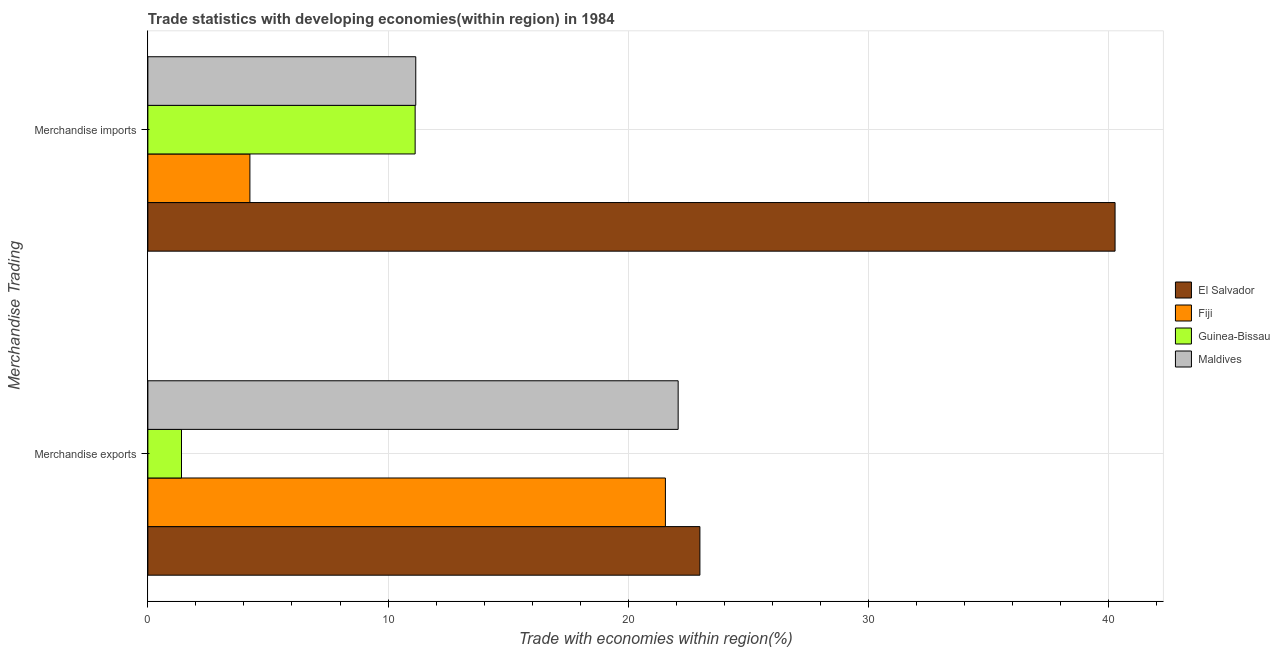What is the label of the 2nd group of bars from the top?
Keep it short and to the point. Merchandise exports. What is the merchandise imports in Fiji?
Make the answer very short. 4.25. Across all countries, what is the maximum merchandise exports?
Your answer should be compact. 22.98. Across all countries, what is the minimum merchandise imports?
Keep it short and to the point. 4.25. In which country was the merchandise imports maximum?
Give a very brief answer. El Salvador. In which country was the merchandise imports minimum?
Your answer should be very brief. Fiji. What is the total merchandise exports in the graph?
Your response must be concise. 68.01. What is the difference between the merchandise exports in Guinea-Bissau and that in Fiji?
Offer a very short reply. -20.15. What is the difference between the merchandise exports in Fiji and the merchandise imports in Guinea-Bissau?
Make the answer very short. 10.42. What is the average merchandise imports per country?
Provide a short and direct response. 16.7. What is the difference between the merchandise exports and merchandise imports in El Salvador?
Your answer should be very brief. -17.28. In how many countries, is the merchandise exports greater than 12 %?
Your response must be concise. 3. What is the ratio of the merchandise exports in El Salvador to that in Fiji?
Your answer should be compact. 1.07. Is the merchandise imports in Maldives less than that in Guinea-Bissau?
Give a very brief answer. No. What does the 1st bar from the top in Merchandise exports represents?
Offer a terse response. Maldives. What does the 3rd bar from the bottom in Merchandise imports represents?
Your answer should be compact. Guinea-Bissau. How many bars are there?
Give a very brief answer. 8. Are all the bars in the graph horizontal?
Offer a very short reply. Yes. How many countries are there in the graph?
Provide a short and direct response. 4. Are the values on the major ticks of X-axis written in scientific E-notation?
Keep it short and to the point. No. Does the graph contain any zero values?
Make the answer very short. No. Does the graph contain grids?
Your answer should be very brief. Yes. Where does the legend appear in the graph?
Provide a succinct answer. Center right. How many legend labels are there?
Make the answer very short. 4. How are the legend labels stacked?
Provide a succinct answer. Vertical. What is the title of the graph?
Provide a short and direct response. Trade statistics with developing economies(within region) in 1984. What is the label or title of the X-axis?
Provide a short and direct response. Trade with economies within region(%). What is the label or title of the Y-axis?
Your answer should be very brief. Merchandise Trading. What is the Trade with economies within region(%) in El Salvador in Merchandise exports?
Make the answer very short. 22.98. What is the Trade with economies within region(%) in Fiji in Merchandise exports?
Offer a terse response. 21.55. What is the Trade with economies within region(%) in Guinea-Bissau in Merchandise exports?
Provide a succinct answer. 1.4. What is the Trade with economies within region(%) in Maldives in Merchandise exports?
Provide a short and direct response. 22.08. What is the Trade with economies within region(%) in El Salvador in Merchandise imports?
Provide a succinct answer. 40.27. What is the Trade with economies within region(%) of Fiji in Merchandise imports?
Ensure brevity in your answer.  4.25. What is the Trade with economies within region(%) of Guinea-Bissau in Merchandise imports?
Offer a terse response. 11.13. What is the Trade with economies within region(%) in Maldives in Merchandise imports?
Your response must be concise. 11.15. Across all Merchandise Trading, what is the maximum Trade with economies within region(%) of El Salvador?
Your answer should be very brief. 40.27. Across all Merchandise Trading, what is the maximum Trade with economies within region(%) in Fiji?
Give a very brief answer. 21.55. Across all Merchandise Trading, what is the maximum Trade with economies within region(%) of Guinea-Bissau?
Ensure brevity in your answer.  11.13. Across all Merchandise Trading, what is the maximum Trade with economies within region(%) in Maldives?
Your answer should be compact. 22.08. Across all Merchandise Trading, what is the minimum Trade with economies within region(%) in El Salvador?
Make the answer very short. 22.98. Across all Merchandise Trading, what is the minimum Trade with economies within region(%) of Fiji?
Provide a succinct answer. 4.25. Across all Merchandise Trading, what is the minimum Trade with economies within region(%) in Guinea-Bissau?
Offer a terse response. 1.4. Across all Merchandise Trading, what is the minimum Trade with economies within region(%) in Maldives?
Keep it short and to the point. 11.15. What is the total Trade with economies within region(%) in El Salvador in the graph?
Keep it short and to the point. 63.25. What is the total Trade with economies within region(%) in Fiji in the graph?
Ensure brevity in your answer.  25.79. What is the total Trade with economies within region(%) of Guinea-Bissau in the graph?
Offer a terse response. 12.53. What is the total Trade with economies within region(%) in Maldives in the graph?
Provide a succinct answer. 33.23. What is the difference between the Trade with economies within region(%) in El Salvador in Merchandise exports and that in Merchandise imports?
Offer a very short reply. -17.28. What is the difference between the Trade with economies within region(%) in Fiji in Merchandise exports and that in Merchandise imports?
Offer a terse response. 17.3. What is the difference between the Trade with economies within region(%) in Guinea-Bissau in Merchandise exports and that in Merchandise imports?
Your answer should be compact. -9.73. What is the difference between the Trade with economies within region(%) of Maldives in Merchandise exports and that in Merchandise imports?
Provide a succinct answer. 10.92. What is the difference between the Trade with economies within region(%) in El Salvador in Merchandise exports and the Trade with economies within region(%) in Fiji in Merchandise imports?
Provide a short and direct response. 18.73. What is the difference between the Trade with economies within region(%) in El Salvador in Merchandise exports and the Trade with economies within region(%) in Guinea-Bissau in Merchandise imports?
Provide a succinct answer. 11.86. What is the difference between the Trade with economies within region(%) of El Salvador in Merchandise exports and the Trade with economies within region(%) of Maldives in Merchandise imports?
Your response must be concise. 11.83. What is the difference between the Trade with economies within region(%) of Fiji in Merchandise exports and the Trade with economies within region(%) of Guinea-Bissau in Merchandise imports?
Offer a very short reply. 10.42. What is the difference between the Trade with economies within region(%) of Fiji in Merchandise exports and the Trade with economies within region(%) of Maldives in Merchandise imports?
Your response must be concise. 10.39. What is the difference between the Trade with economies within region(%) in Guinea-Bissau in Merchandise exports and the Trade with economies within region(%) in Maldives in Merchandise imports?
Provide a short and direct response. -9.75. What is the average Trade with economies within region(%) of El Salvador per Merchandise Trading?
Your answer should be very brief. 31.62. What is the average Trade with economies within region(%) in Fiji per Merchandise Trading?
Give a very brief answer. 12.9. What is the average Trade with economies within region(%) in Guinea-Bissau per Merchandise Trading?
Give a very brief answer. 6.26. What is the average Trade with economies within region(%) in Maldives per Merchandise Trading?
Offer a very short reply. 16.61. What is the difference between the Trade with economies within region(%) in El Salvador and Trade with economies within region(%) in Fiji in Merchandise exports?
Provide a short and direct response. 1.44. What is the difference between the Trade with economies within region(%) of El Salvador and Trade with economies within region(%) of Guinea-Bissau in Merchandise exports?
Your answer should be compact. 21.58. What is the difference between the Trade with economies within region(%) of El Salvador and Trade with economies within region(%) of Maldives in Merchandise exports?
Your answer should be very brief. 0.91. What is the difference between the Trade with economies within region(%) of Fiji and Trade with economies within region(%) of Guinea-Bissau in Merchandise exports?
Your answer should be compact. 20.15. What is the difference between the Trade with economies within region(%) in Fiji and Trade with economies within region(%) in Maldives in Merchandise exports?
Ensure brevity in your answer.  -0.53. What is the difference between the Trade with economies within region(%) in Guinea-Bissau and Trade with economies within region(%) in Maldives in Merchandise exports?
Keep it short and to the point. -20.68. What is the difference between the Trade with economies within region(%) of El Salvador and Trade with economies within region(%) of Fiji in Merchandise imports?
Provide a short and direct response. 36.02. What is the difference between the Trade with economies within region(%) in El Salvador and Trade with economies within region(%) in Guinea-Bissau in Merchandise imports?
Give a very brief answer. 29.14. What is the difference between the Trade with economies within region(%) of El Salvador and Trade with economies within region(%) of Maldives in Merchandise imports?
Your answer should be very brief. 29.11. What is the difference between the Trade with economies within region(%) of Fiji and Trade with economies within region(%) of Guinea-Bissau in Merchandise imports?
Offer a terse response. -6.88. What is the difference between the Trade with economies within region(%) of Fiji and Trade with economies within region(%) of Maldives in Merchandise imports?
Your response must be concise. -6.91. What is the difference between the Trade with economies within region(%) in Guinea-Bissau and Trade with economies within region(%) in Maldives in Merchandise imports?
Your response must be concise. -0.03. What is the ratio of the Trade with economies within region(%) of El Salvador in Merchandise exports to that in Merchandise imports?
Your answer should be compact. 0.57. What is the ratio of the Trade with economies within region(%) of Fiji in Merchandise exports to that in Merchandise imports?
Offer a terse response. 5.07. What is the ratio of the Trade with economies within region(%) of Guinea-Bissau in Merchandise exports to that in Merchandise imports?
Provide a short and direct response. 0.13. What is the ratio of the Trade with economies within region(%) in Maldives in Merchandise exports to that in Merchandise imports?
Make the answer very short. 1.98. What is the difference between the highest and the second highest Trade with economies within region(%) of El Salvador?
Your answer should be very brief. 17.28. What is the difference between the highest and the second highest Trade with economies within region(%) of Fiji?
Ensure brevity in your answer.  17.3. What is the difference between the highest and the second highest Trade with economies within region(%) of Guinea-Bissau?
Ensure brevity in your answer.  9.73. What is the difference between the highest and the second highest Trade with economies within region(%) in Maldives?
Provide a short and direct response. 10.92. What is the difference between the highest and the lowest Trade with economies within region(%) in El Salvador?
Your answer should be very brief. 17.28. What is the difference between the highest and the lowest Trade with economies within region(%) in Fiji?
Keep it short and to the point. 17.3. What is the difference between the highest and the lowest Trade with economies within region(%) in Guinea-Bissau?
Give a very brief answer. 9.73. What is the difference between the highest and the lowest Trade with economies within region(%) of Maldives?
Keep it short and to the point. 10.92. 